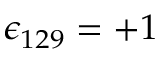Convert formula to latex. <formula><loc_0><loc_0><loc_500><loc_500>\epsilon _ { 1 2 9 } = + 1</formula> 